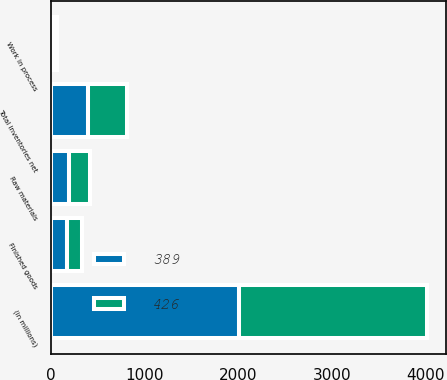Convert chart. <chart><loc_0><loc_0><loc_500><loc_500><stacked_bar_chart><ecel><fcel>(in millions)<fcel>Finished goods<fcel>Work in process<fcel>Raw materials<fcel>Total inventories net<nl><fcel>426<fcel>2011<fcel>168<fcel>31<fcel>227<fcel>426<nl><fcel>389<fcel>2010<fcel>166<fcel>32<fcel>191<fcel>389<nl></chart> 